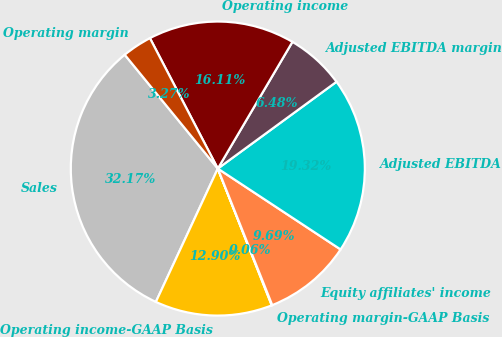Convert chart to OTSL. <chart><loc_0><loc_0><loc_500><loc_500><pie_chart><fcel>Sales<fcel>Operating income-GAAP Basis<fcel>Operating margin-GAAP Basis<fcel>Equity affiliates' income<fcel>Adjusted EBITDA<fcel>Adjusted EBITDA margin<fcel>Operating income<fcel>Operating margin<nl><fcel>32.17%<fcel>12.9%<fcel>0.06%<fcel>9.69%<fcel>19.32%<fcel>6.48%<fcel>16.11%<fcel>3.27%<nl></chart> 